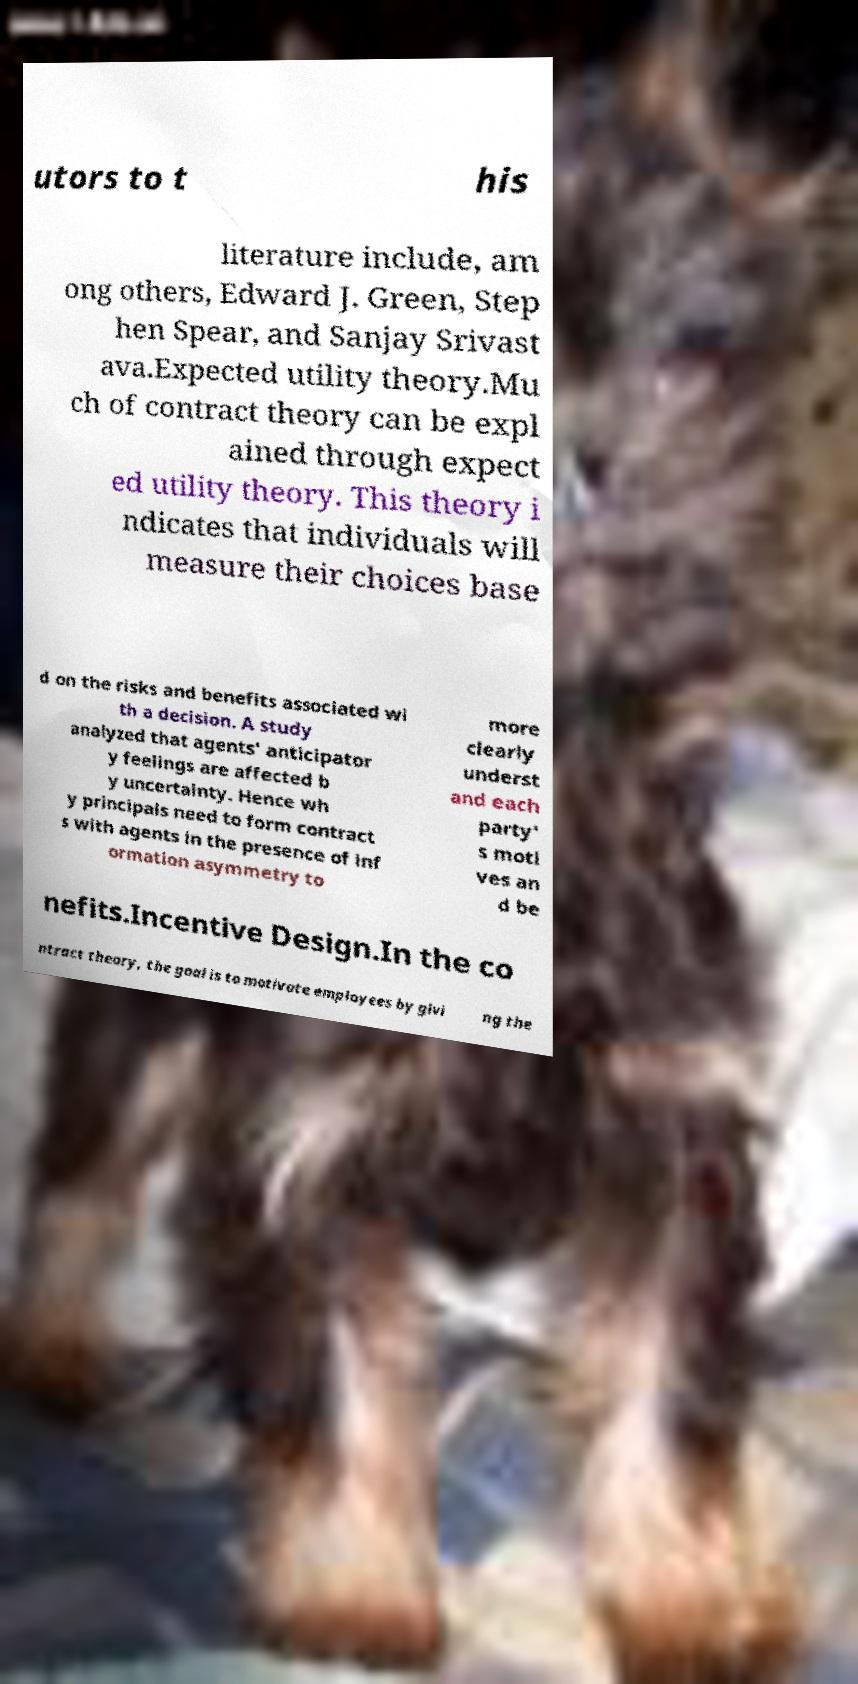I need the written content from this picture converted into text. Can you do that? utors to t his literature include, am ong others, Edward J. Green, Step hen Spear, and Sanjay Srivast ava.Expected utility theory.Mu ch of contract theory can be expl ained through expect ed utility theory. This theory i ndicates that individuals will measure their choices base d on the risks and benefits associated wi th a decision. A study analyzed that agents' anticipator y feelings are affected b y uncertainty. Hence wh y principals need to form contract s with agents in the presence of inf ormation asymmetry to more clearly underst and each party' s moti ves an d be nefits.Incentive Design.In the co ntract theory, the goal is to motivate employees by givi ng the 